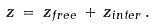<formula> <loc_0><loc_0><loc_500><loc_500>z \, = \, z _ { f r e e } \, + \, z _ { i n t e r } \, .</formula> 